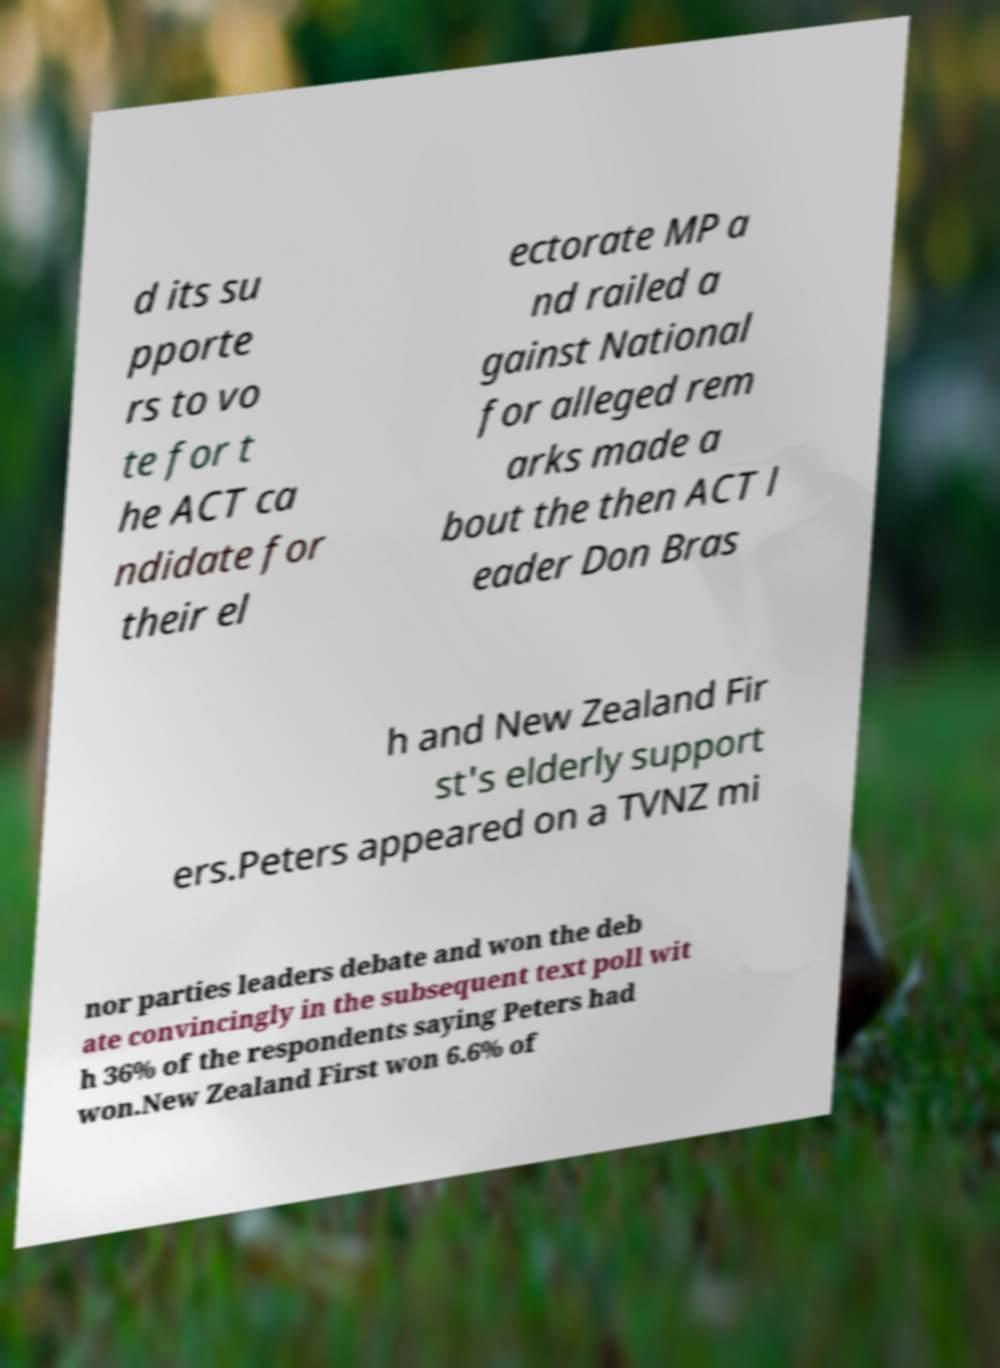Please identify and transcribe the text found in this image. d its su pporte rs to vo te for t he ACT ca ndidate for their el ectorate MP a nd railed a gainst National for alleged rem arks made a bout the then ACT l eader Don Bras h and New Zealand Fir st's elderly support ers.Peters appeared on a TVNZ mi nor parties leaders debate and won the deb ate convincingly in the subsequent text poll wit h 36% of the respondents saying Peters had won.New Zealand First won 6.6% of 